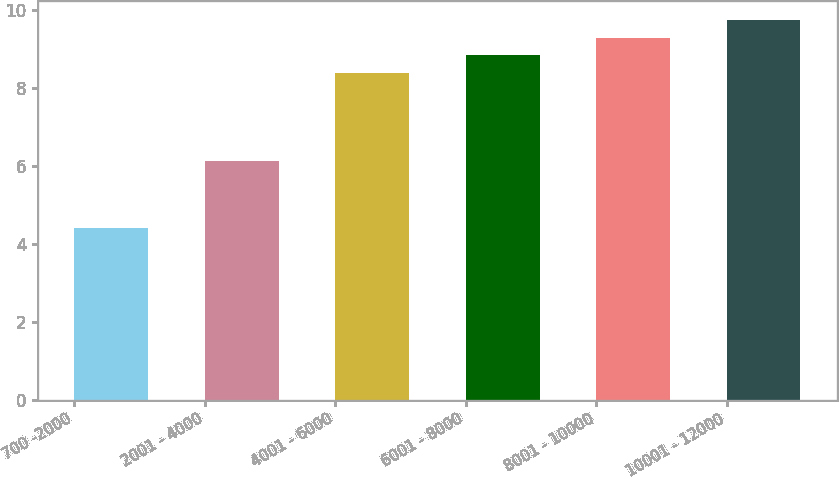Convert chart to OTSL. <chart><loc_0><loc_0><loc_500><loc_500><bar_chart><fcel>700 -2000<fcel>2001 - 4000<fcel>4001 - 6000<fcel>6001 - 8000<fcel>8001 - 10000<fcel>10001 - 12000<nl><fcel>4.4<fcel>6.13<fcel>8.38<fcel>8.83<fcel>9.28<fcel>9.73<nl></chart> 